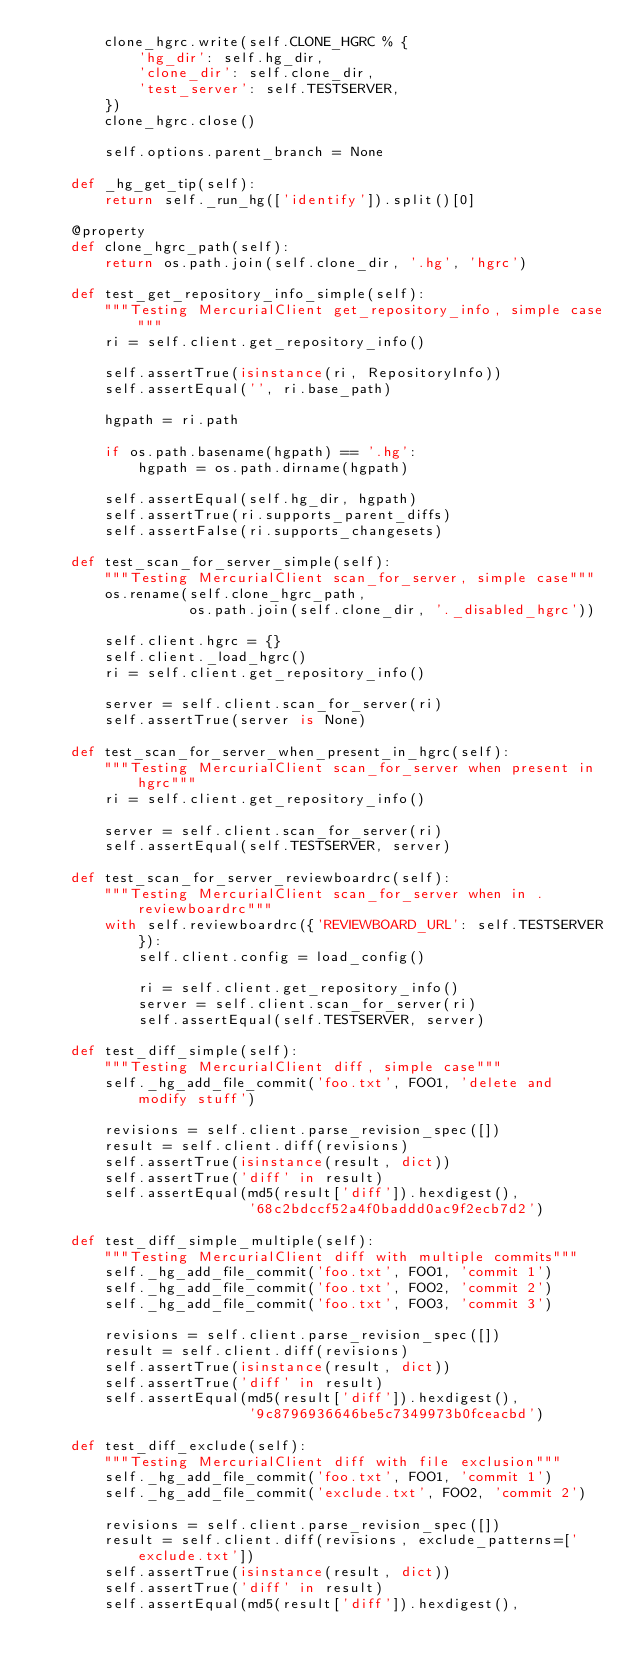Convert code to text. <code><loc_0><loc_0><loc_500><loc_500><_Python_>        clone_hgrc.write(self.CLONE_HGRC % {
            'hg_dir': self.hg_dir,
            'clone_dir': self.clone_dir,
            'test_server': self.TESTSERVER,
        })
        clone_hgrc.close()

        self.options.parent_branch = None

    def _hg_get_tip(self):
        return self._run_hg(['identify']).split()[0]

    @property
    def clone_hgrc_path(self):
        return os.path.join(self.clone_dir, '.hg', 'hgrc')

    def test_get_repository_info_simple(self):
        """Testing MercurialClient get_repository_info, simple case"""
        ri = self.client.get_repository_info()

        self.assertTrue(isinstance(ri, RepositoryInfo))
        self.assertEqual('', ri.base_path)

        hgpath = ri.path

        if os.path.basename(hgpath) == '.hg':
            hgpath = os.path.dirname(hgpath)

        self.assertEqual(self.hg_dir, hgpath)
        self.assertTrue(ri.supports_parent_diffs)
        self.assertFalse(ri.supports_changesets)

    def test_scan_for_server_simple(self):
        """Testing MercurialClient scan_for_server, simple case"""
        os.rename(self.clone_hgrc_path,
                  os.path.join(self.clone_dir, '._disabled_hgrc'))

        self.client.hgrc = {}
        self.client._load_hgrc()
        ri = self.client.get_repository_info()

        server = self.client.scan_for_server(ri)
        self.assertTrue(server is None)

    def test_scan_for_server_when_present_in_hgrc(self):
        """Testing MercurialClient scan_for_server when present in hgrc"""
        ri = self.client.get_repository_info()

        server = self.client.scan_for_server(ri)
        self.assertEqual(self.TESTSERVER, server)

    def test_scan_for_server_reviewboardrc(self):
        """Testing MercurialClient scan_for_server when in .reviewboardrc"""
        with self.reviewboardrc({'REVIEWBOARD_URL': self.TESTSERVER}):
            self.client.config = load_config()

            ri = self.client.get_repository_info()
            server = self.client.scan_for_server(ri)
            self.assertEqual(self.TESTSERVER, server)

    def test_diff_simple(self):
        """Testing MercurialClient diff, simple case"""
        self._hg_add_file_commit('foo.txt', FOO1, 'delete and modify stuff')

        revisions = self.client.parse_revision_spec([])
        result = self.client.diff(revisions)
        self.assertTrue(isinstance(result, dict))
        self.assertTrue('diff' in result)
        self.assertEqual(md5(result['diff']).hexdigest(),
                         '68c2bdccf52a4f0baddd0ac9f2ecb7d2')

    def test_diff_simple_multiple(self):
        """Testing MercurialClient diff with multiple commits"""
        self._hg_add_file_commit('foo.txt', FOO1, 'commit 1')
        self._hg_add_file_commit('foo.txt', FOO2, 'commit 2')
        self._hg_add_file_commit('foo.txt', FOO3, 'commit 3')

        revisions = self.client.parse_revision_spec([])
        result = self.client.diff(revisions)
        self.assertTrue(isinstance(result, dict))
        self.assertTrue('diff' in result)
        self.assertEqual(md5(result['diff']).hexdigest(),
                         '9c8796936646be5c7349973b0fceacbd')

    def test_diff_exclude(self):
        """Testing MercurialClient diff with file exclusion"""
        self._hg_add_file_commit('foo.txt', FOO1, 'commit 1')
        self._hg_add_file_commit('exclude.txt', FOO2, 'commit 2')

        revisions = self.client.parse_revision_spec([])
        result = self.client.diff(revisions, exclude_patterns=['exclude.txt'])
        self.assertTrue(isinstance(result, dict))
        self.assertTrue('diff' in result)
        self.assertEqual(md5(result['diff']).hexdigest(),</code> 